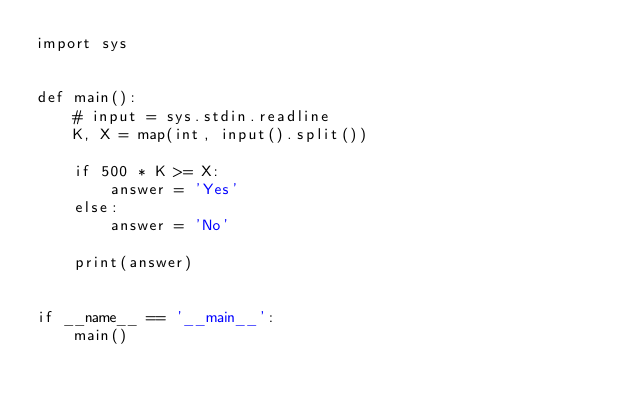<code> <loc_0><loc_0><loc_500><loc_500><_Python_>import sys


def main():
    # input = sys.stdin.readline
    K, X = map(int, input().split())

    if 500 * K >= X:
        answer = 'Yes'
    else:
        answer = 'No'

    print(answer)


if __name__ == '__main__':
    main()
</code> 